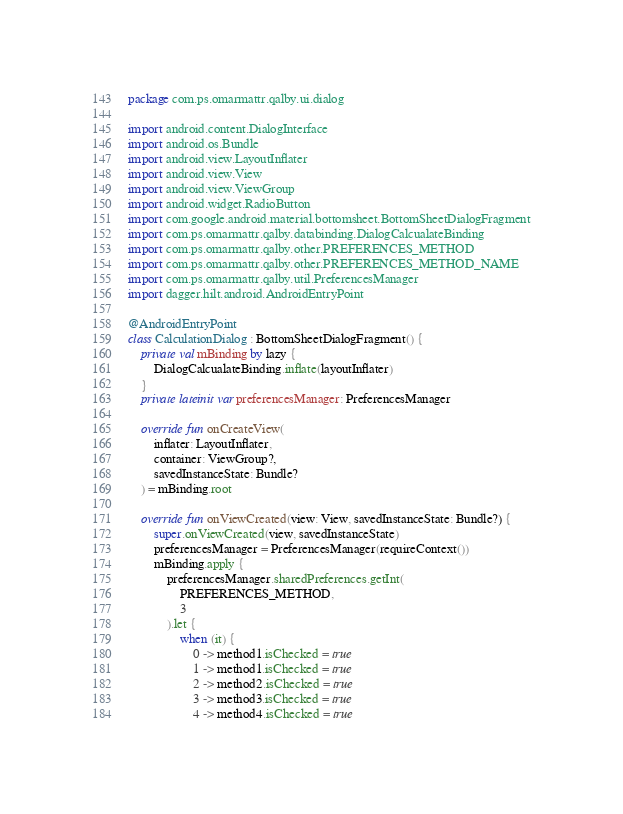Convert code to text. <code><loc_0><loc_0><loc_500><loc_500><_Kotlin_>package com.ps.omarmattr.qalby.ui.dialog

import android.content.DialogInterface
import android.os.Bundle
import android.view.LayoutInflater
import android.view.View
import android.view.ViewGroup
import android.widget.RadioButton
import com.google.android.material.bottomsheet.BottomSheetDialogFragment
import com.ps.omarmattr.qalby.databinding.DialogCalcualateBinding
import com.ps.omarmattr.qalby.other.PREFERENCES_METHOD
import com.ps.omarmattr.qalby.other.PREFERENCES_METHOD_NAME
import com.ps.omarmattr.qalby.util.PreferencesManager
import dagger.hilt.android.AndroidEntryPoint

@AndroidEntryPoint
class CalculationDialog : BottomSheetDialogFragment() {
    private val mBinding by lazy {
        DialogCalcualateBinding.inflate(layoutInflater)
    }
    private lateinit var preferencesManager: PreferencesManager

    override fun onCreateView(
        inflater: LayoutInflater,
        container: ViewGroup?,
        savedInstanceState: Bundle?
    ) = mBinding.root

    override fun onViewCreated(view: View, savedInstanceState: Bundle?) {
        super.onViewCreated(view, savedInstanceState)
        preferencesManager = PreferencesManager(requireContext())
        mBinding.apply {
            preferencesManager.sharedPreferences.getInt(
                PREFERENCES_METHOD,
                3
            ).let {
                when (it) {
                    0 -> method1.isChecked = true
                    1 -> method1.isChecked = true
                    2 -> method2.isChecked = true
                    3 -> method3.isChecked = true
                    4 -> method4.isChecked = true</code> 